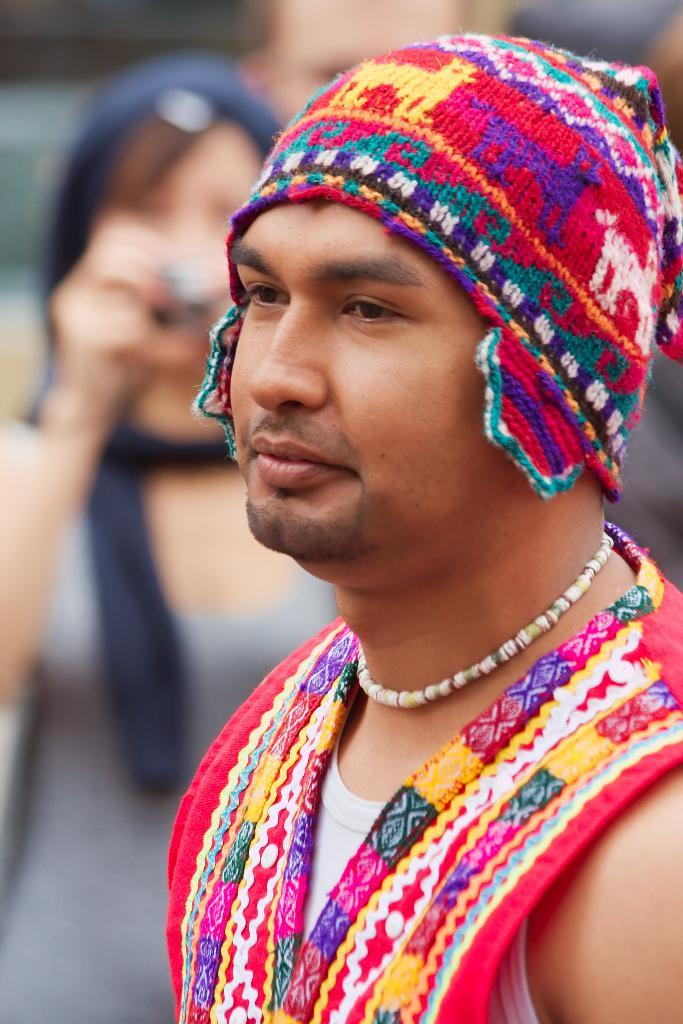Who is the main subject in the image? There is a man in the image. What is the man wearing on his head? The man is wearing a cap. Can you describe the people in the background of the image? There are multiple persons in the background of the image. How is the background of the image depicted? The background of the image is blurred. What unit of measurement is used to determine the distance between the man and the group in the image? The image does not provide any information about the distance between the man and the group, nor does it mention any unit of measurement. 